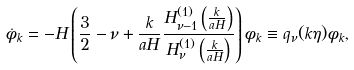Convert formula to latex. <formula><loc_0><loc_0><loc_500><loc_500>\dot { \phi } _ { k } = - H \left ( \frac { 3 } { 2 } - \nu + \frac { k } { a H } \frac { H _ { \nu - 1 } ^ { ( 1 ) } \left ( \frac { k } { a H } \right ) } { H _ { \nu } ^ { ( 1 ) } \left ( \frac { k } { a H } \right ) } \right ) \phi _ { k } \equiv q _ { \nu } ( k \eta ) \phi _ { k } ,</formula> 